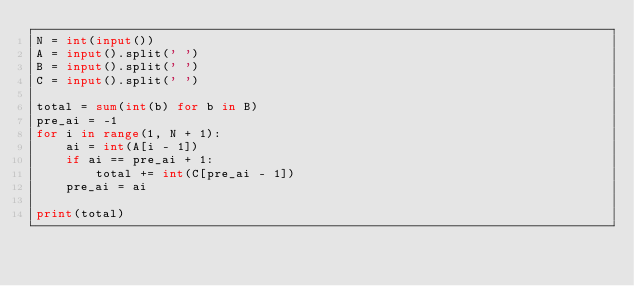Convert code to text. <code><loc_0><loc_0><loc_500><loc_500><_Python_>N = int(input())
A = input().split(' ')
B = input().split(' ')
C = input().split(' ')

total = sum(int(b) for b in B)
pre_ai = -1
for i in range(1, N + 1):
    ai = int(A[i - 1])
    if ai == pre_ai + 1:
        total += int(C[pre_ai - 1])
    pre_ai = ai

print(total)</code> 